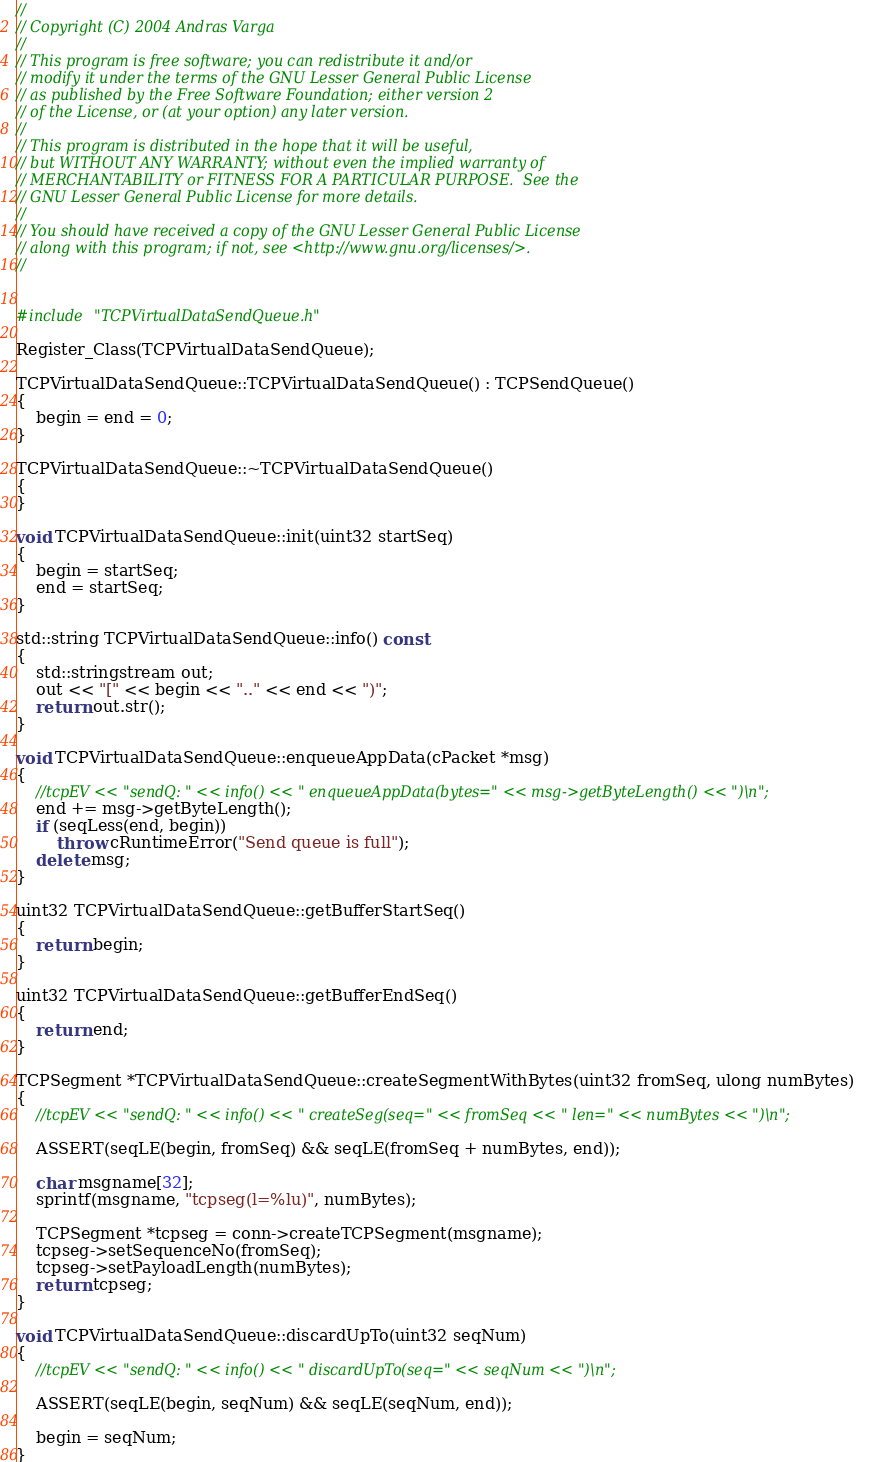<code> <loc_0><loc_0><loc_500><loc_500><_C++_>//
// Copyright (C) 2004 Andras Varga
//
// This program is free software; you can redistribute it and/or
// modify it under the terms of the GNU Lesser General Public License
// as published by the Free Software Foundation; either version 2
// of the License, or (at your option) any later version.
//
// This program is distributed in the hope that it will be useful,
// but WITHOUT ANY WARRANTY; without even the implied warranty of
// MERCHANTABILITY or FITNESS FOR A PARTICULAR PURPOSE.  See the
// GNU Lesser General Public License for more details.
//
// You should have received a copy of the GNU Lesser General Public License
// along with this program; if not, see <http://www.gnu.org/licenses/>.
//


#include "TCPVirtualDataSendQueue.h"

Register_Class(TCPVirtualDataSendQueue);

TCPVirtualDataSendQueue::TCPVirtualDataSendQueue() : TCPSendQueue()
{
    begin = end = 0;
}

TCPVirtualDataSendQueue::~TCPVirtualDataSendQueue()
{
}

void TCPVirtualDataSendQueue::init(uint32 startSeq)
{
    begin = startSeq;
    end = startSeq;
}

std::string TCPVirtualDataSendQueue::info() const
{
    std::stringstream out;
    out << "[" << begin << ".." << end << ")";
    return out.str();
}

void TCPVirtualDataSendQueue::enqueueAppData(cPacket *msg)
{
    //tcpEV << "sendQ: " << info() << " enqueueAppData(bytes=" << msg->getByteLength() << ")\n";
    end += msg->getByteLength();
    if (seqLess(end, begin))
        throw cRuntimeError("Send queue is full");
    delete msg;
}

uint32 TCPVirtualDataSendQueue::getBufferStartSeq()
{
    return begin;
}

uint32 TCPVirtualDataSendQueue::getBufferEndSeq()
{
    return end;
}

TCPSegment *TCPVirtualDataSendQueue::createSegmentWithBytes(uint32 fromSeq, ulong numBytes)
{
    //tcpEV << "sendQ: " << info() << " createSeg(seq=" << fromSeq << " len=" << numBytes << ")\n";

    ASSERT(seqLE(begin, fromSeq) && seqLE(fromSeq + numBytes, end));

    char msgname[32];
    sprintf(msgname, "tcpseg(l=%lu)", numBytes);

    TCPSegment *tcpseg = conn->createTCPSegment(msgname);
    tcpseg->setSequenceNo(fromSeq);
    tcpseg->setPayloadLength(numBytes);
    return tcpseg;
}

void TCPVirtualDataSendQueue::discardUpTo(uint32 seqNum)
{
    //tcpEV << "sendQ: " << info() << " discardUpTo(seq=" << seqNum << ")\n";

    ASSERT(seqLE(begin, seqNum) && seqLE(seqNum, end));

    begin = seqNum;
}
</code> 